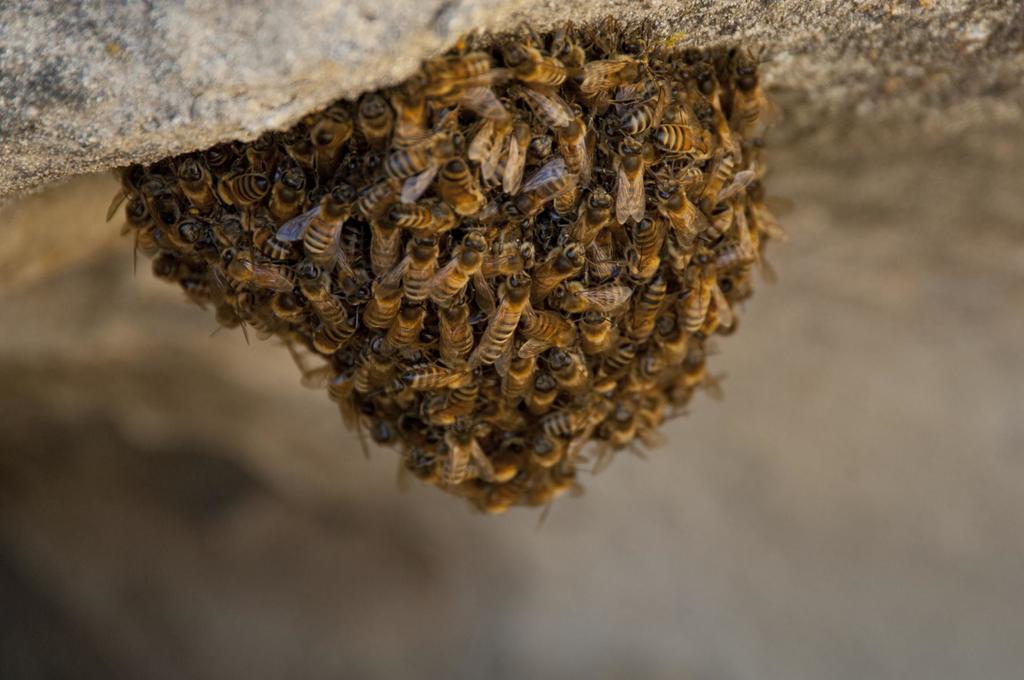Could you give a brief overview of what you see in this image? At the top of the image there is a stone. On the stone there is a honeycomb with honey bees. 